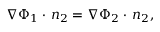<formula> <loc_0><loc_0><loc_500><loc_500>\nabla \Phi _ { 1 } \cdot \, n _ { 2 } = \nabla \Phi _ { 2 } \cdot \, n _ { 2 } ,</formula> 